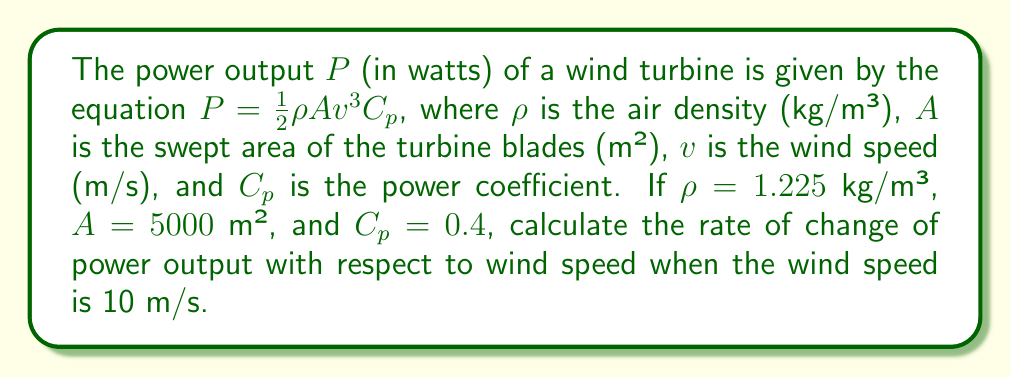Solve this math problem. To solve this problem, we need to find the derivative of the power output function with respect to wind speed and then evaluate it at the given wind speed.

1) Given power output function:
   $P = \frac{1}{2}\rho A v^3 C_p$

2) Substitute the given values:
   $P = \frac{1}{2} \cdot 1.225 \cdot 5000 \cdot v^3 \cdot 0.4$

3) Simplify:
   $P = 1225 v^3$

4) To find the rate of change, we need to differentiate P with respect to v:
   $$\frac{dP}{dv} = 1225 \cdot 3v^2 = 3675v^2$$

5) Now, we evaluate this at v = 10 m/s:
   $$\frac{dP}{dv}\bigg|_{v=10} = 3675 \cdot 10^2 = 367500$$

Therefore, the rate of change of power output with respect to wind speed when the wind speed is 10 m/s is 367,500 W/(m/s) or 367.5 kW/(m/s).
Answer: $367.5$ kW/(m/s) 